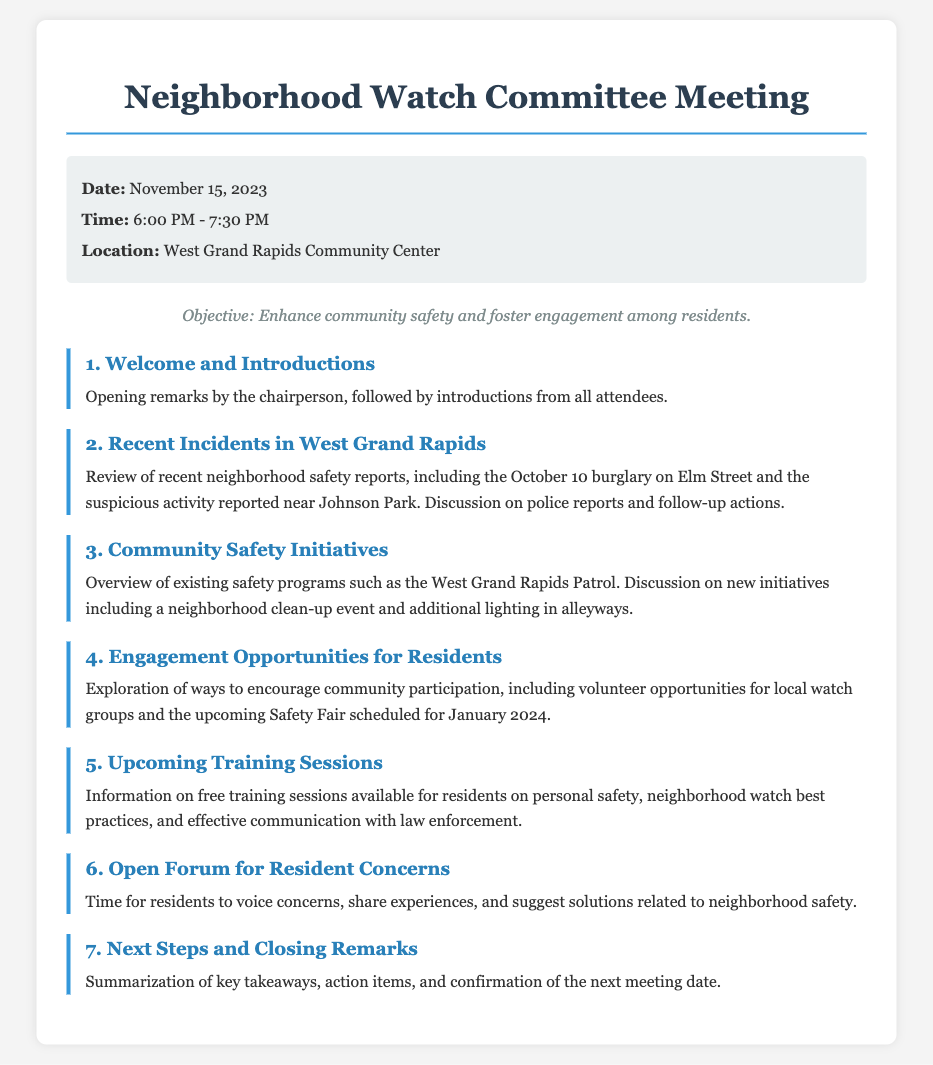What is the date of the meeting? The meeting date is stated in the meeting-info section of the document.
Answer: November 15, 2023 What time does the meeting start? The start time for the meeting is listed in the meeting-info section of the document.
Answer: 6:00 PM Who is giving the opening remarks? The opening remarks are given by the chairperson, as mentioned in the first agenda item.
Answer: Chairperson What recent incident is mentioned first in the discussions? The first incident discussed is provided in the second agenda item focusing on neighborhood safety reports.
Answer: October 10 burglary on Elm Street What is one of the initiatives discussed for community safety? The initiatives are outlined in the third agenda item, which highlights various community safety efforts.
Answer: Neighborhood clean-up event What is the purpose of the upcoming Safety Fair? The Safety Fair is mentioned in the agenda as part of engaging residents and improving community participation.
Answer: Community participation How long is the meeting scheduled to last? The duration of the meeting can be inferred from the meeting time indicated in the meeting-info section.
Answer: 1.5 hours What training sessions are being offered to residents? The details of training sessions are mentioned in the fifth agenda item, indicating the subjects for the sessions.
Answer: Personal safety What is the item number for the Open Forum discussion? The numbering of the agenda items provides a clear sequence for each discussion point in the document.
Answer: 6 